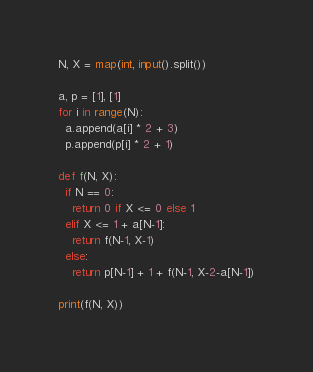<code> <loc_0><loc_0><loc_500><loc_500><_Python_>N, X = map(int, input().split())

a, p = [1], [1]
for i in range(N):
  a.append(a[i] * 2 + 3)
  p.append(p[i] * 2 + 1)

def f(N, X):
  if N == 0:
    return 0 if X <= 0 else 1
  elif X <= 1 + a[N-1]:
    return f(N-1, X-1)
  else:
    return p[N-1] + 1 + f(N-1, X-2-a[N-1])

print(f(N, X))</code> 